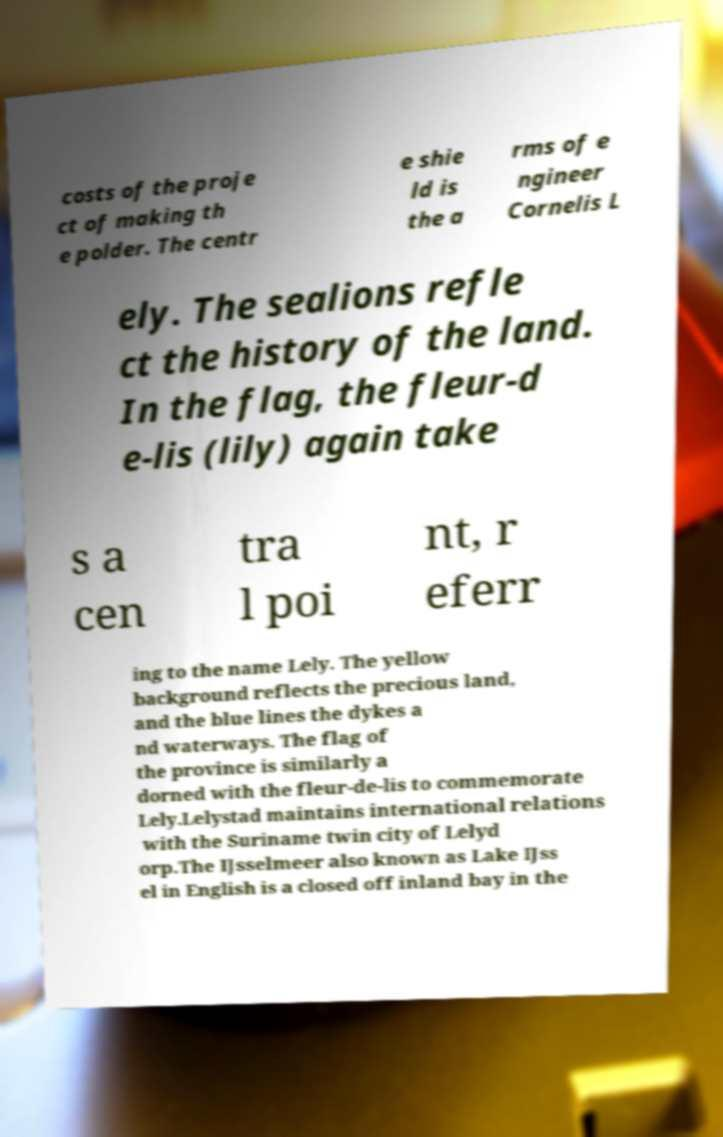For documentation purposes, I need the text within this image transcribed. Could you provide that? costs of the proje ct of making th e polder. The centr e shie ld is the a rms of e ngineer Cornelis L ely. The sealions refle ct the history of the land. In the flag, the fleur-d e-lis (lily) again take s a cen tra l poi nt, r eferr ing to the name Lely. The yellow background reflects the precious land, and the blue lines the dykes a nd waterways. The flag of the province is similarly a dorned with the fleur-de-lis to commemorate Lely.Lelystad maintains international relations with the Suriname twin city of Lelyd orp.The IJsselmeer also known as Lake IJss el in English is a closed off inland bay in the 